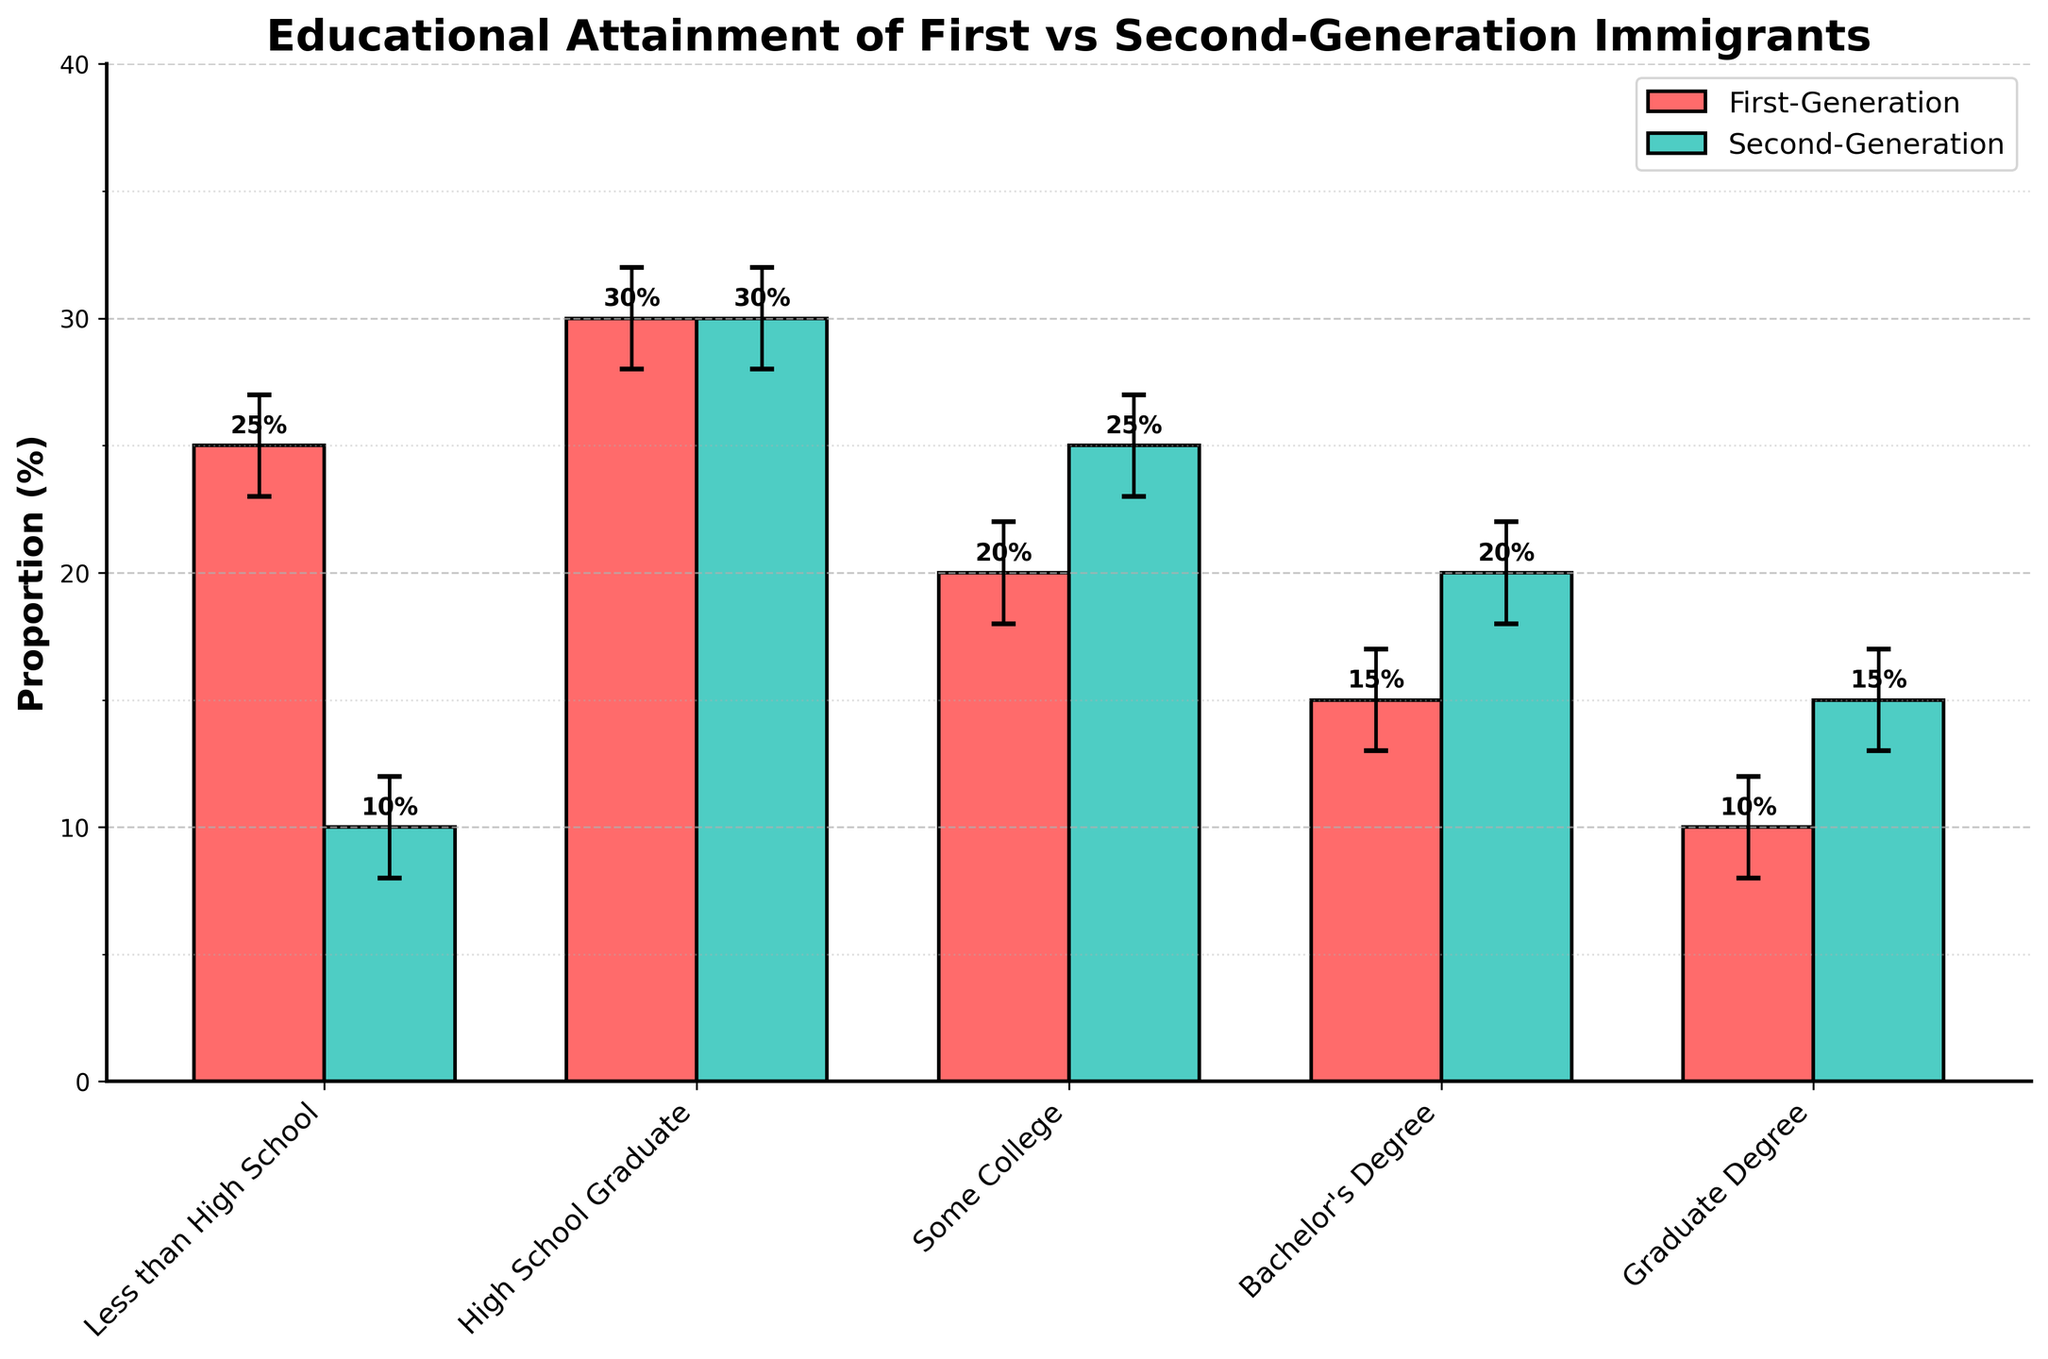What is the title of the figure? The title of the figure is written at the top of the visualization.
Answer: Educational Attainment of First vs Second-Generation Immigrants What is the proportion of first-generation immigrants with a Bachelor's Degree? Observe the bar for First-Generation under Bachelor's Degree. The height represents the proportion.
Answer: 15% Which educational level has the same proportion for both first and second-generation immigrants? Compare the proportions for each educational level for both generations and identify where they are equal.
Answer: High School Graduate What is the difference in the proportion of first-generation and second-generation immigrants with less than a high school education? Subtract the proportion of second-generation immigrants from the proportion of first-generation immigrants for Less than High School.
Answer: 15% Which generation has a higher proportion of immigrants with graduate degrees, and by how much? Compare the proportions for Graduate Degree for both generations and calculate the difference.
Answer: Second-Generation by 5% What is the range of the confidence interval for second-generation immigrants with some college education? Look at the upper and lower bounds of the confidence interval for Second-Generation under Some College. Subtract the lower bound from the upper bound.
Answer: 4% Which group shows a larger variation within the confidence intervals for Bachelor's Degree? Compare the ranges of the confidence intervals for Bachelor's Degree between both generations.
Answer: First-Generation For which educational level is the proportion of second-generation immigrants nearly double that of first-generation immigrants? Compare the proportions of each educational level for both generations and identify where the second-generation value is almost twice the first-generation value.
Answer: Less than High School How does the proportion of second-generation immigrants with a Bachelor's Degree compare to the proportion of first-generation immigrants with Some College? Compare the proportions represented by the height of the bars for Second-Generation under Bachelor's Degree and First-Generation under Some College.
Answer: Second-Generation with Bachelor's Degree is higher by 5% What is the total proportion of first-generation immigrants with at least a Bachelor's Degree (Bachelor's Degree + Graduate Degree)? Add the proportions of First-Generation under Bachelor's Degree and Graduate Degree.
Answer: 25% 